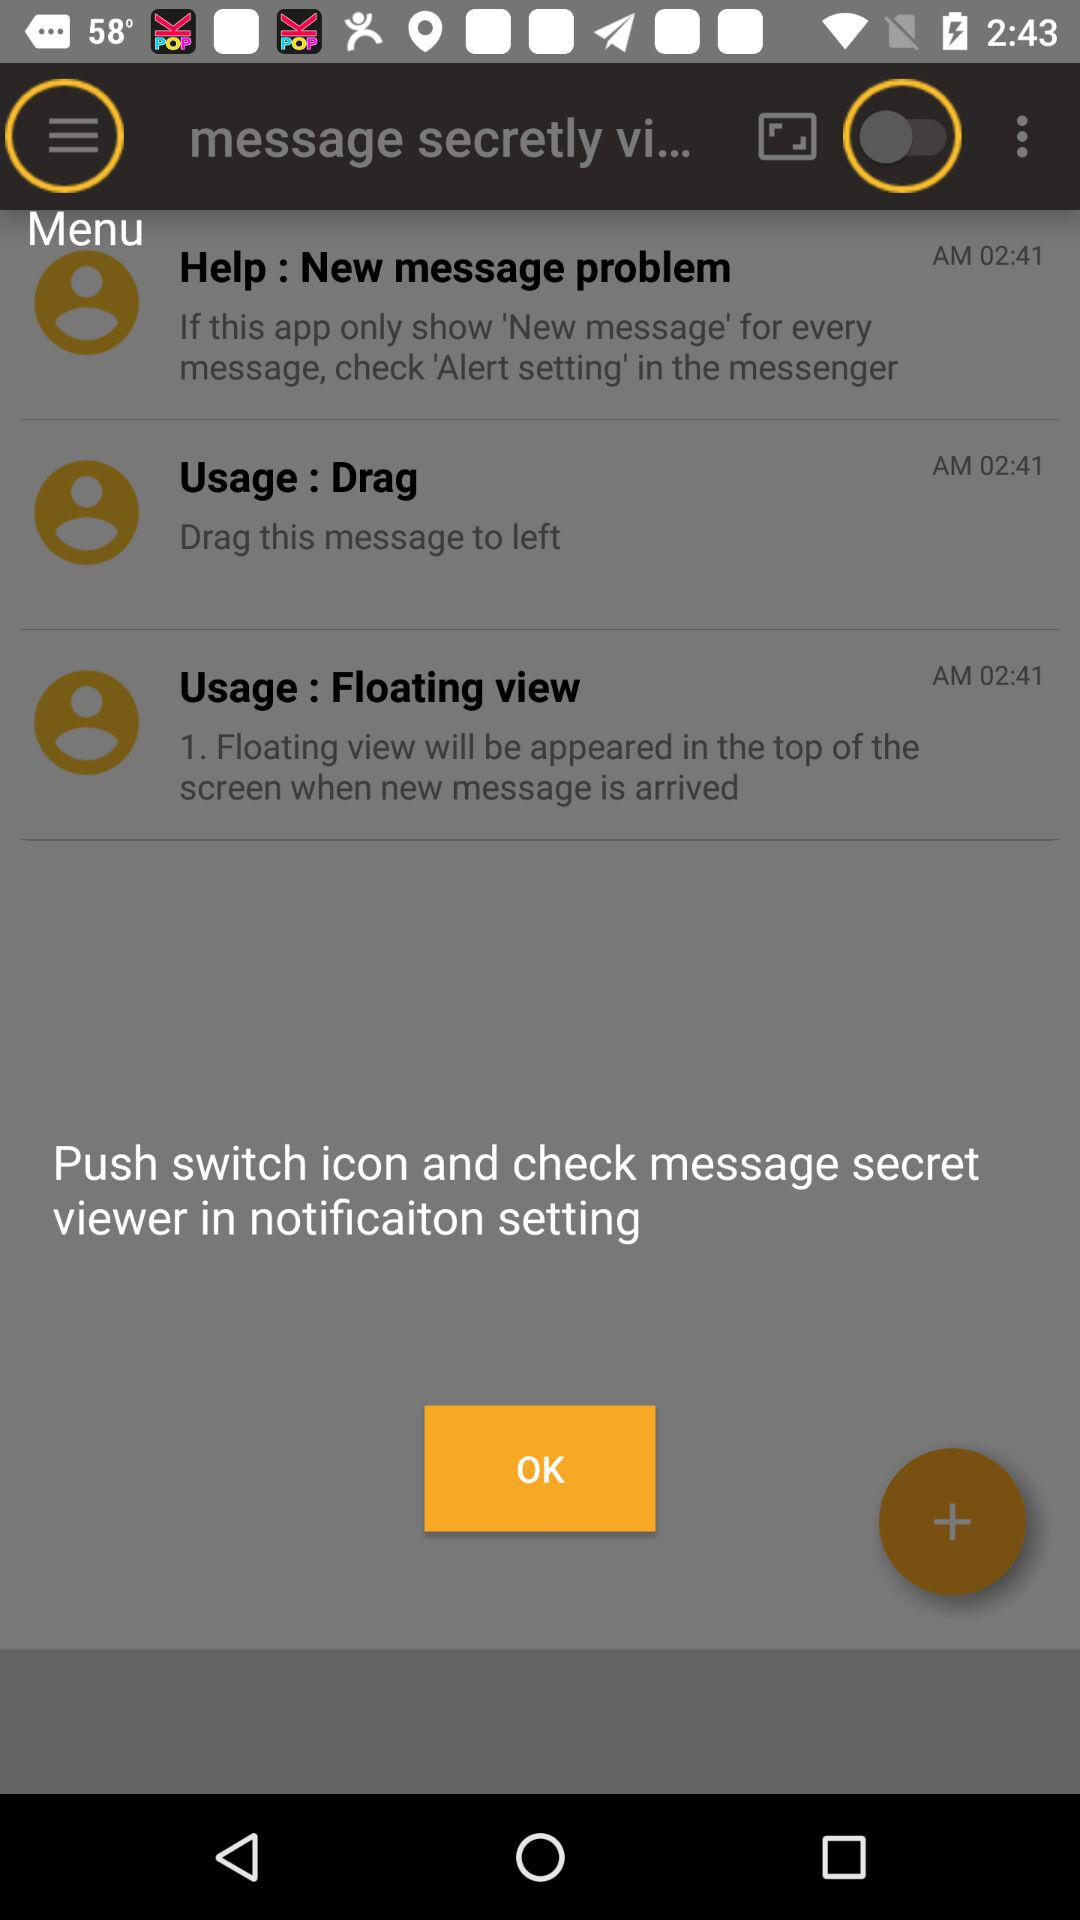What is the status of "message secretly vi..."? The status is "off". 